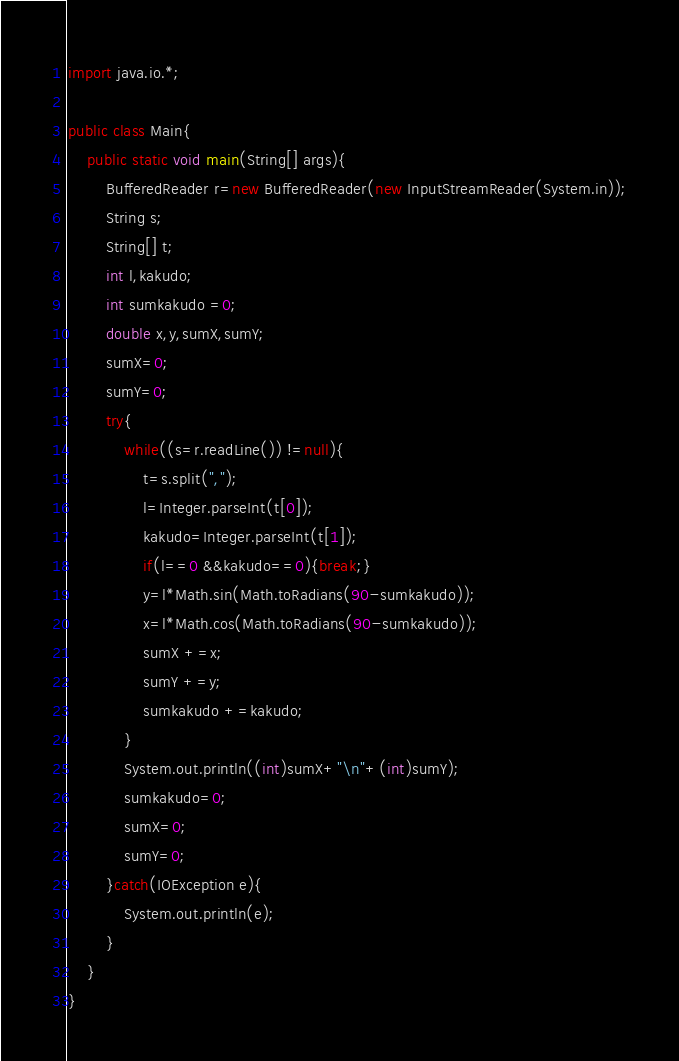Convert code to text. <code><loc_0><loc_0><loc_500><loc_500><_Java_>import java.io.*;

public class Main{
	public static void main(String[] args){
		BufferedReader r=new BufferedReader(new InputStreamReader(System.in));
		String s;
		String[] t;
		int l,kakudo;
		int sumkakudo =0;
		double x,y,sumX,sumY;
		sumX=0;
		sumY=0;
		try{
			while((s=r.readLine()) !=null){
				t=s.split(",");
				l=Integer.parseInt(t[0]);
				kakudo=Integer.parseInt(t[1]);
				if(l==0 &&kakudo==0){break;}
				y=l*Math.sin(Math.toRadians(90-sumkakudo));
				x=l*Math.cos(Math.toRadians(90-sumkakudo));
				sumX +=x;
				sumY +=y;
				sumkakudo +=kakudo;
			}
			System.out.println((int)sumX+"\n"+(int)sumY);
			sumkakudo=0;
			sumX=0;
			sumY=0;
		}catch(IOException e){
			System.out.println(e);
		}
	}
}</code> 